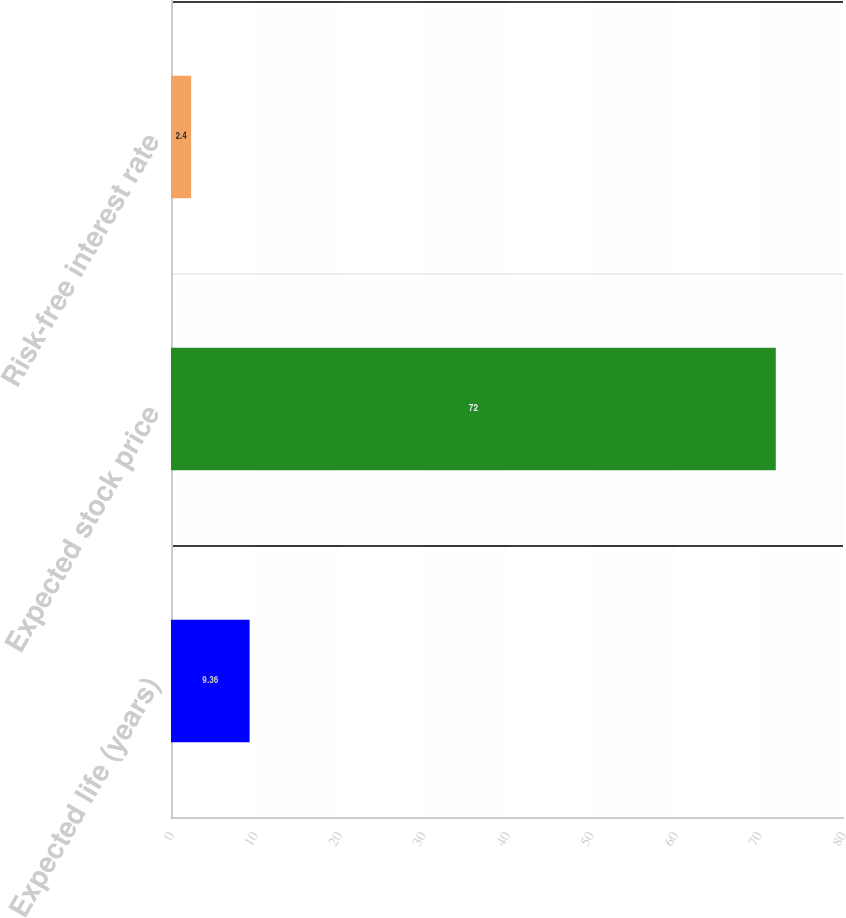Convert chart. <chart><loc_0><loc_0><loc_500><loc_500><bar_chart><fcel>Expected life (years)<fcel>Expected stock price<fcel>Risk-free interest rate<nl><fcel>9.36<fcel>72<fcel>2.4<nl></chart> 